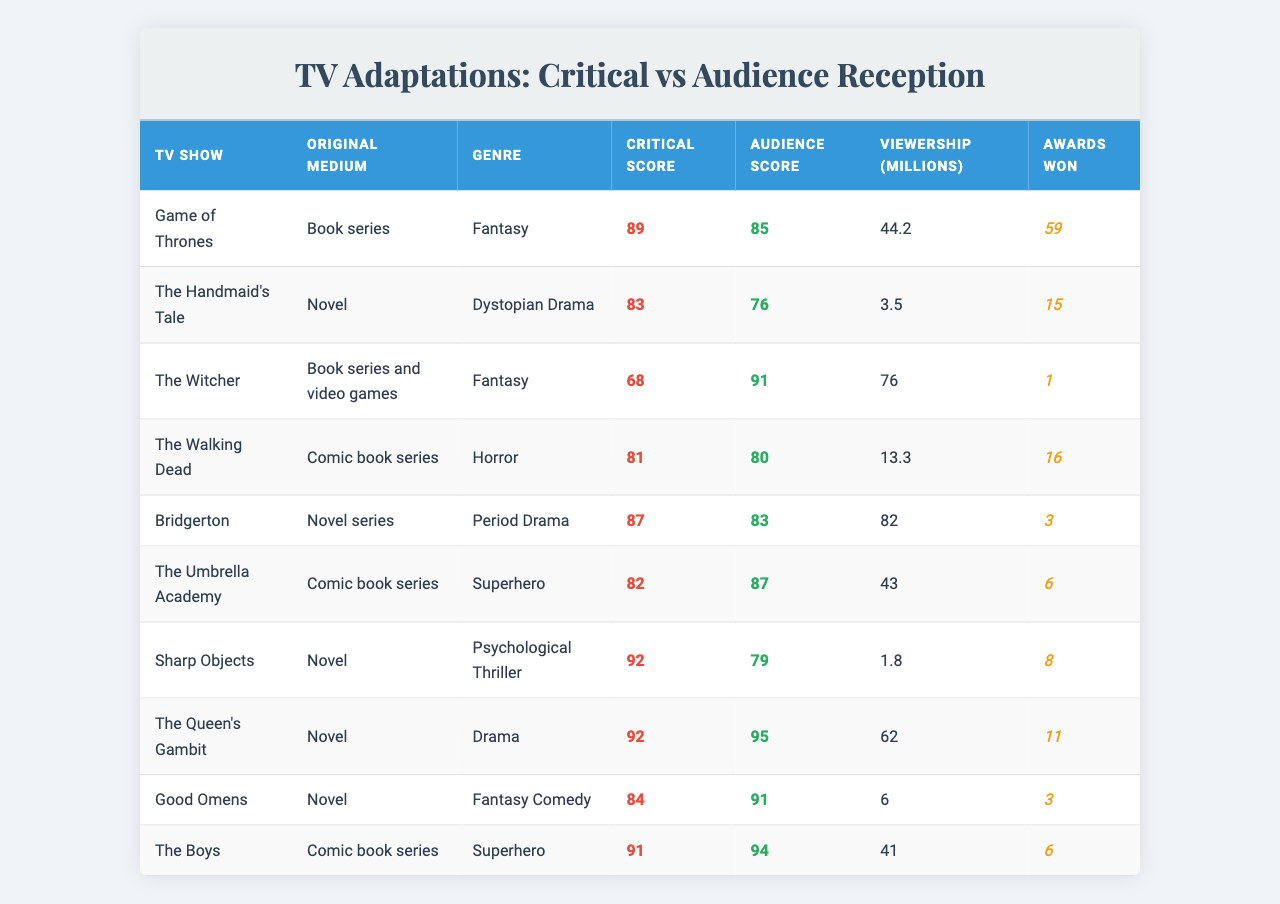What is the critical score of "The Queen's Gambit"? The critical score of "The Queen's Gambit" is listed as 92 in the table.
Answer: 92 What is the audience score for "The Walking Dead"? The audience score for "The Walking Dead" is shown as 80 in the table.
Answer: 80 Which show has the highest viewership? By checking the viewership column, "The Witcher" has the highest viewership at 76 million.
Answer: 76 million What is the difference between the critical score and audience score for "Bridgerton"? The critical score for "Bridgerton" is 87 and the audience score is 83. The difference is 87 - 83 = 4.
Answer: 4 Are there any shows with a higher audience score than critical score? "The Witcher", "Good Omens", and "The Boys" have audience scores (91, 91, 94) higher than their critical scores (68, 84, 91).
Answer: Yes What is the average critical score of all shows listed? To find the average, sum all critical scores: 89 + 83 + 68 + 81 + 87 + 82 + 92 + 92 + 84 + 91 =  878. There are 10 shows, so the average is 878/10 = 87.8.
Answer: 87.8 How many awards did "Game of Thrones" win compared to "The Handmaid's Tale"? "Game of Thrones" won 59 awards while "The Handmaid's Tale" won 15 awards. The difference is 59 - 15 = 44 awards.
Answer: 44 awards What genre does "Sharp Objects" belong to and what is its critical score? "Sharp Objects" falls under the genre of Psychological Thriller, and its critical score is 92, as indicated in the table.
Answer: Psychological Thriller, 92 Which TV show with an original medium of a comic book has the lowest critical score? "The Umbrella Academy" (82) and "The Walking Dead" (81) are the shows based on comic books. "The Walking Dead" has the lower critical score.
Answer: The Walking Dead What is the total number of awards won by the shows in the Dystopian Drama and Horror genres? "The Handmaid's Tale" won 15 awards and "The Walking Dead" won 16 awards. Total awards = 15 + 16 = 31.
Answer: 31 Which show has the largest difference between its critical score and audience score? The show with the largest difference is "The Witcher", with a difference of 68 (critical) - 91 (audience) = 23.
Answer: 23 